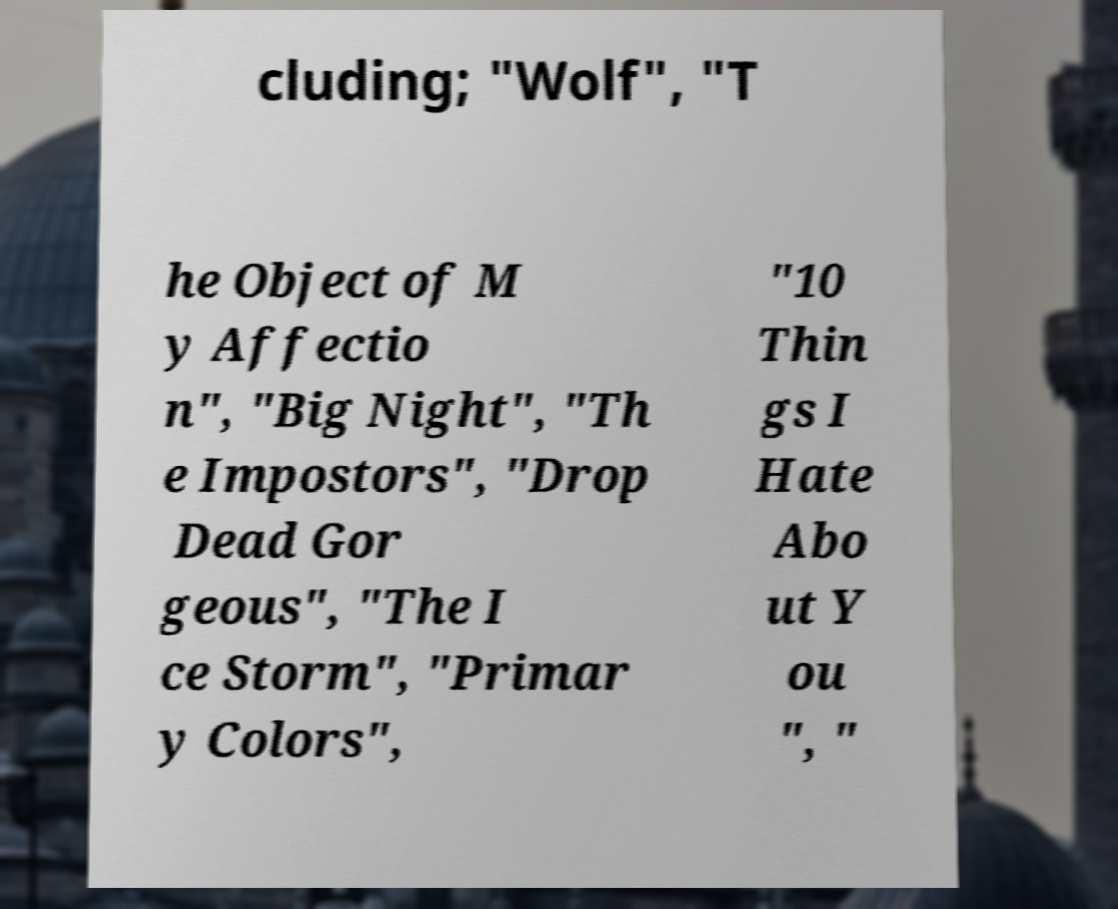Can you accurately transcribe the text from the provided image for me? cluding; "Wolf", "T he Object of M y Affectio n", "Big Night", "Th e Impostors", "Drop Dead Gor geous", "The I ce Storm", "Primar y Colors", "10 Thin gs I Hate Abo ut Y ou ", " 